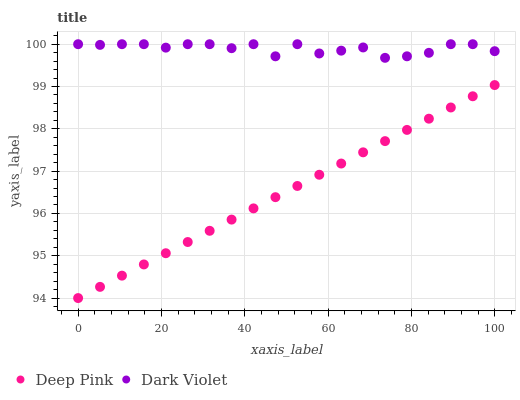Does Deep Pink have the minimum area under the curve?
Answer yes or no. Yes. Does Dark Violet have the maximum area under the curve?
Answer yes or no. Yes. Does Dark Violet have the minimum area under the curve?
Answer yes or no. No. Is Deep Pink the smoothest?
Answer yes or no. Yes. Is Dark Violet the roughest?
Answer yes or no. Yes. Is Dark Violet the smoothest?
Answer yes or no. No. Does Deep Pink have the lowest value?
Answer yes or no. Yes. Does Dark Violet have the lowest value?
Answer yes or no. No. Does Dark Violet have the highest value?
Answer yes or no. Yes. Is Deep Pink less than Dark Violet?
Answer yes or no. Yes. Is Dark Violet greater than Deep Pink?
Answer yes or no. Yes. Does Deep Pink intersect Dark Violet?
Answer yes or no. No. 